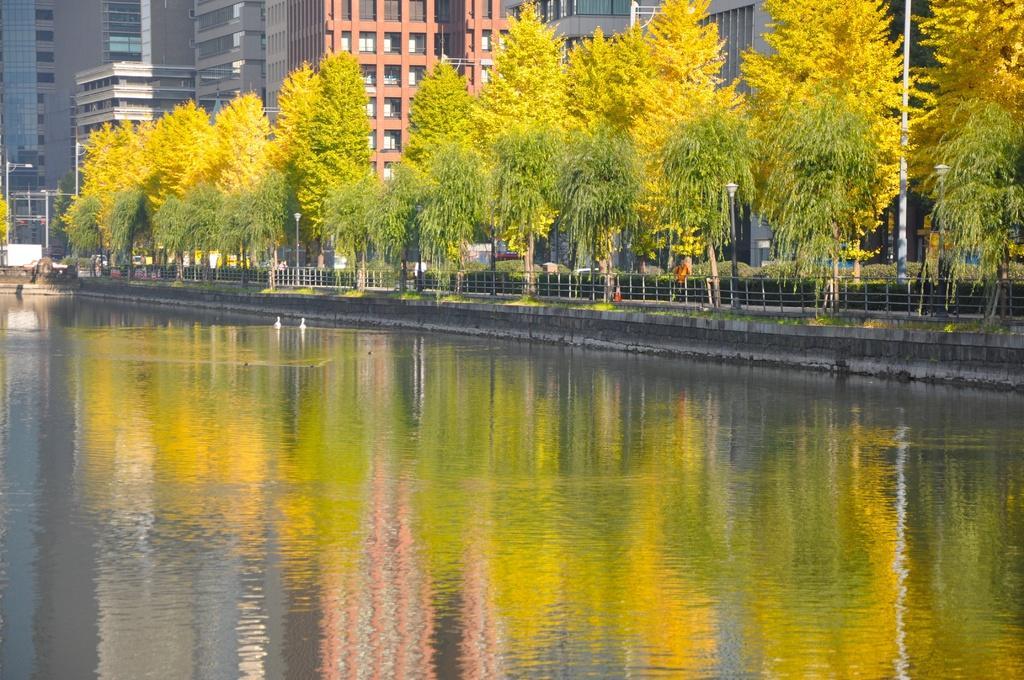Could you give a brief overview of what you see in this image? In the image we can see the buildings and the windows of the buildings. There are even trees, poles and the fence. Here we can see the water, grass and the path. 